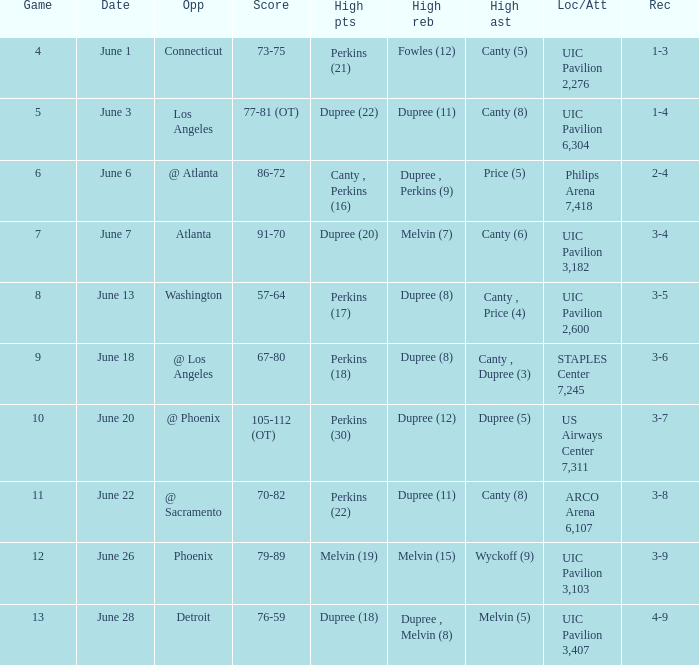What is the date of game 9? June 18. 